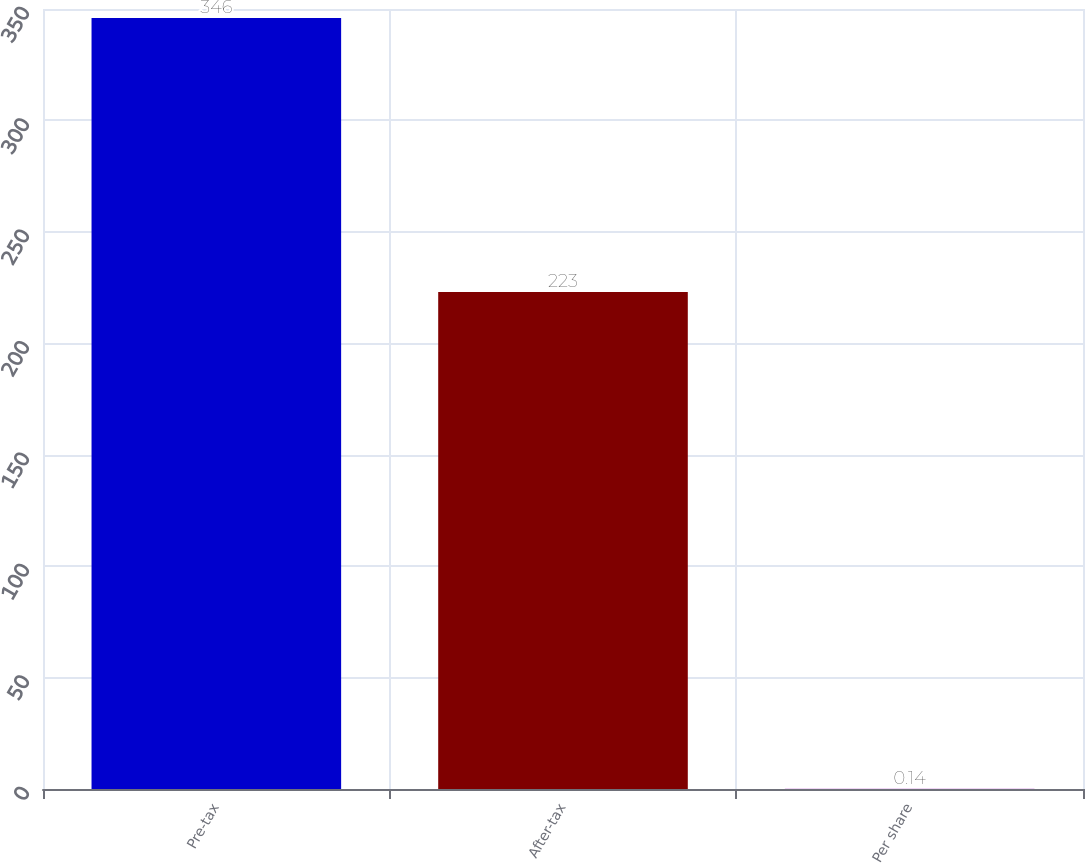<chart> <loc_0><loc_0><loc_500><loc_500><bar_chart><fcel>Pre-tax<fcel>After-tax<fcel>Per share<nl><fcel>346<fcel>223<fcel>0.14<nl></chart> 